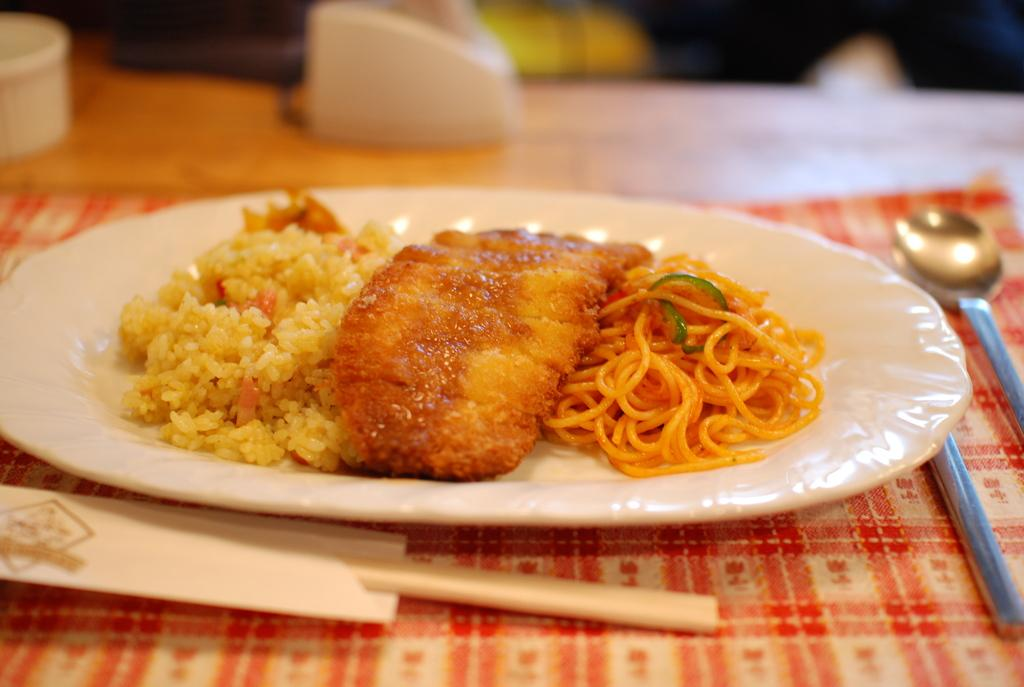What type of food can be seen in the image? There is food in the image, specifically noodles. How are the noodles presented in the image? The noodles are in a white plate. What utensil is visible in the image? There is a spoon in the image. Where is the spoon placed in the image? The spoon is placed on a table top. How many grapes are on the stem in the image? There are no grapes or stems present in the image. 